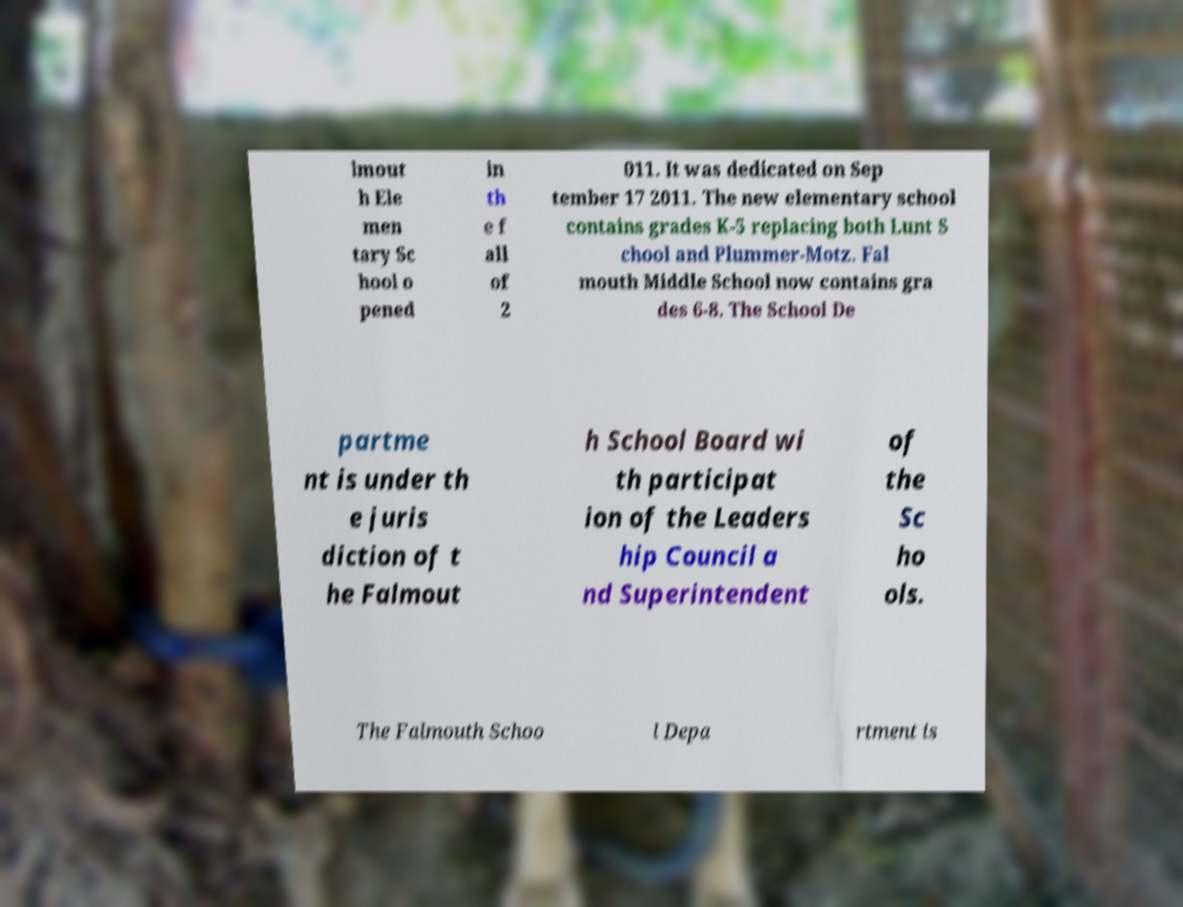Could you assist in decoding the text presented in this image and type it out clearly? lmout h Ele men tary Sc hool o pened in th e f all of 2 011. It was dedicated on Sep tember 17 2011. The new elementary school contains grades K-5 replacing both Lunt S chool and Plummer-Motz. Fal mouth Middle School now contains gra des 6-8. The School De partme nt is under th e juris diction of t he Falmout h School Board wi th participat ion of the Leaders hip Council a nd Superintendent of the Sc ho ols. The Falmouth Schoo l Depa rtment is 